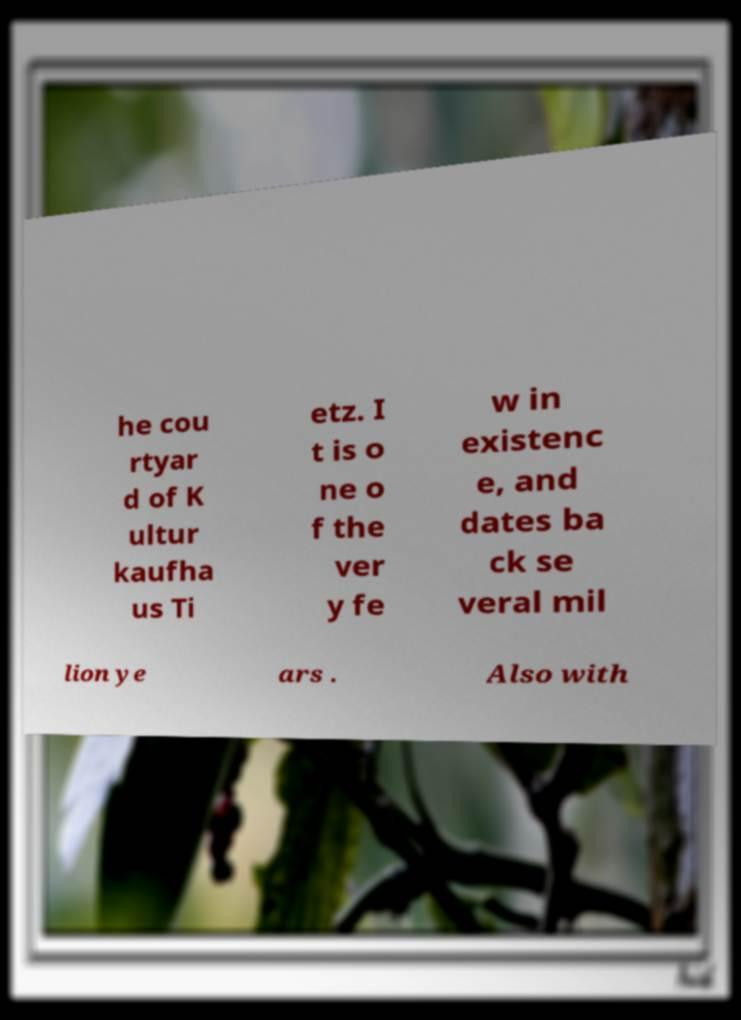Could you extract and type out the text from this image? he cou rtyar d of K ultur kaufha us Ti etz. I t is o ne o f the ver y fe w in existenc e, and dates ba ck se veral mil lion ye ars . Also with 